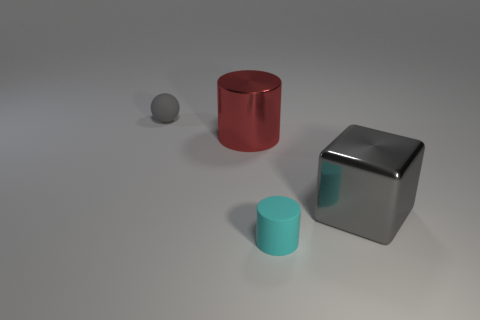Is the material of the big gray block the same as the tiny cyan thing?
Offer a terse response. No. How many spheres are the same material as the cyan thing?
Provide a succinct answer. 1. How many things are rubber objects that are behind the large red object or rubber things that are behind the cube?
Provide a succinct answer. 1. Is the number of large objects in front of the gray shiny cube greater than the number of large red metallic things right of the small cyan rubber object?
Keep it short and to the point. No. What is the color of the large metal object that is in front of the big cylinder?
Make the answer very short. Gray. Is there a tiny brown matte object that has the same shape as the small gray rubber thing?
Ensure brevity in your answer.  No. What number of yellow things are big metallic blocks or small rubber spheres?
Provide a short and direct response. 0. Is there a gray metal block of the same size as the gray matte object?
Give a very brief answer. No. What number of small matte cylinders are there?
Offer a very short reply. 1. What number of small objects are either brown balls or red cylinders?
Provide a succinct answer. 0. 